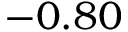<formula> <loc_0><loc_0><loc_500><loc_500>- 0 . 8 0</formula> 